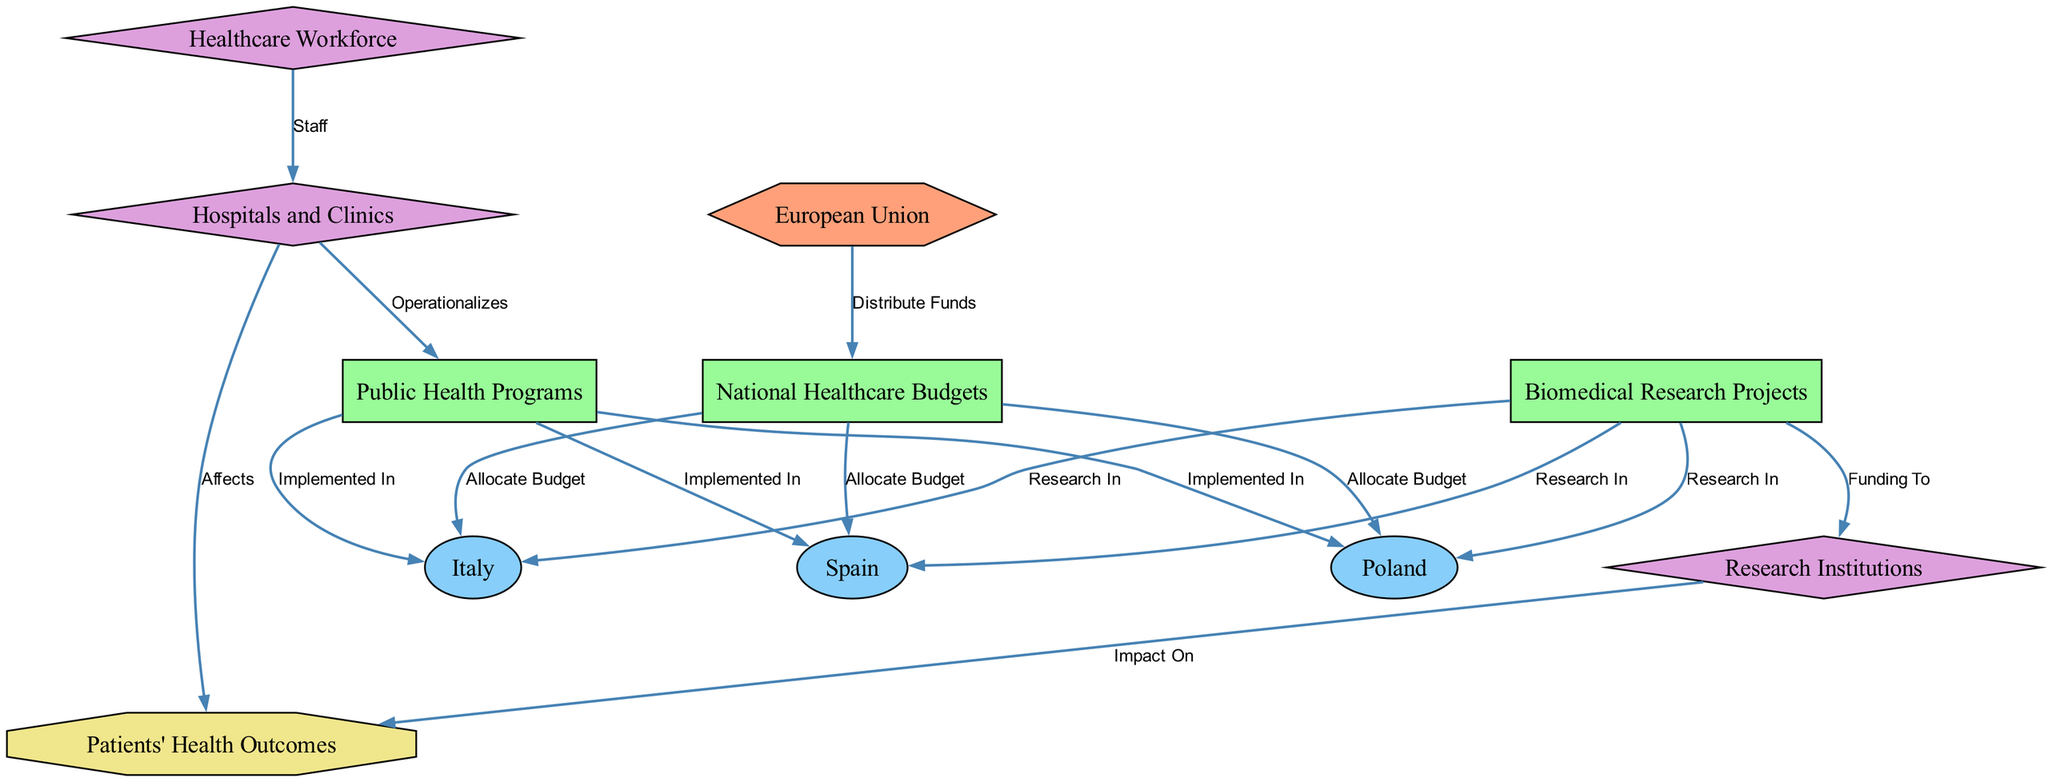What is the primary policy source in the diagram? The primary policy source is identified as "European Union" from the node labeled accordingly. It appears at the top of the diagram, indicating its role in distributing funds.
Answer: European Union How many countries are represented in the diagram? The diagram includes three distinct country nodes: "Spain," "Italy," and "Poland." Thus, a simple count of these nodes yields the total.
Answer: 3 Which entity is directly affected by the "Patients' Health Outcomes"? The diagram shows that both "Research Institutions" and "Hospitals and Clinics" have direct connections leading to "Patients' Health Outcomes." Since the question asks for one, we can point to either, choosing "Research Institutions" for this answer.
Answer: Research Institutions What is the relationship between "National Healthcare Budgets" and "Biomedical Research Projects"? The relationship is that "National Healthcare Budgets" allocate budgets to the countries, which in turn, support "Biomedical Research Projects." The examination of the edges shows that there is no direct edge from "National Healthcare Budgets" to "Biomedical Research Projects"; instead, the connection is through the countries.
Answer: Allocate Budget Which fund destination has the most countries implemented in? By examining the edges, "Public Health Programs" are implemented in all three countries: "Spain," "Italy," and "Poland," making it the fund destination with the widest implementation across the countries.
Answer: Public Health Programs How are "Hospitals and Clinics" operationalized in the diagram? "Hospitals and Clinics" are operationalized through connections from "Healthcare Workforce," which indicates that staff members affect the operational effectiveness of hospitals. The flow indicates that staff are essential for the operationalization of these clinics.
Answer: Staff Which node represents the impact of the funding pipeline on healthcare? The node "Patients' Health Outcomes" is designated as the impact of the overall healthcare funding pipeline. It illustrates how funding and resources affect the health of patients.
Answer: Patients' Health Outcomes What type of node is "Biomedical Research Projects"? In the diagram, "Biomedical Research Projects" is categorized as a fund destination, which can be inferred from its shape and coloring in the node attributes.
Answer: fund destination How do "Research Institutions" influence "Patients' Health Outcomes"? The diagram reveals a direct edge from "Research Institutions" to "Patients' Health Outcomes," indicating that the research conducted in these institutions directly impacts the health outcomes of patients.
Answer: Impact On 